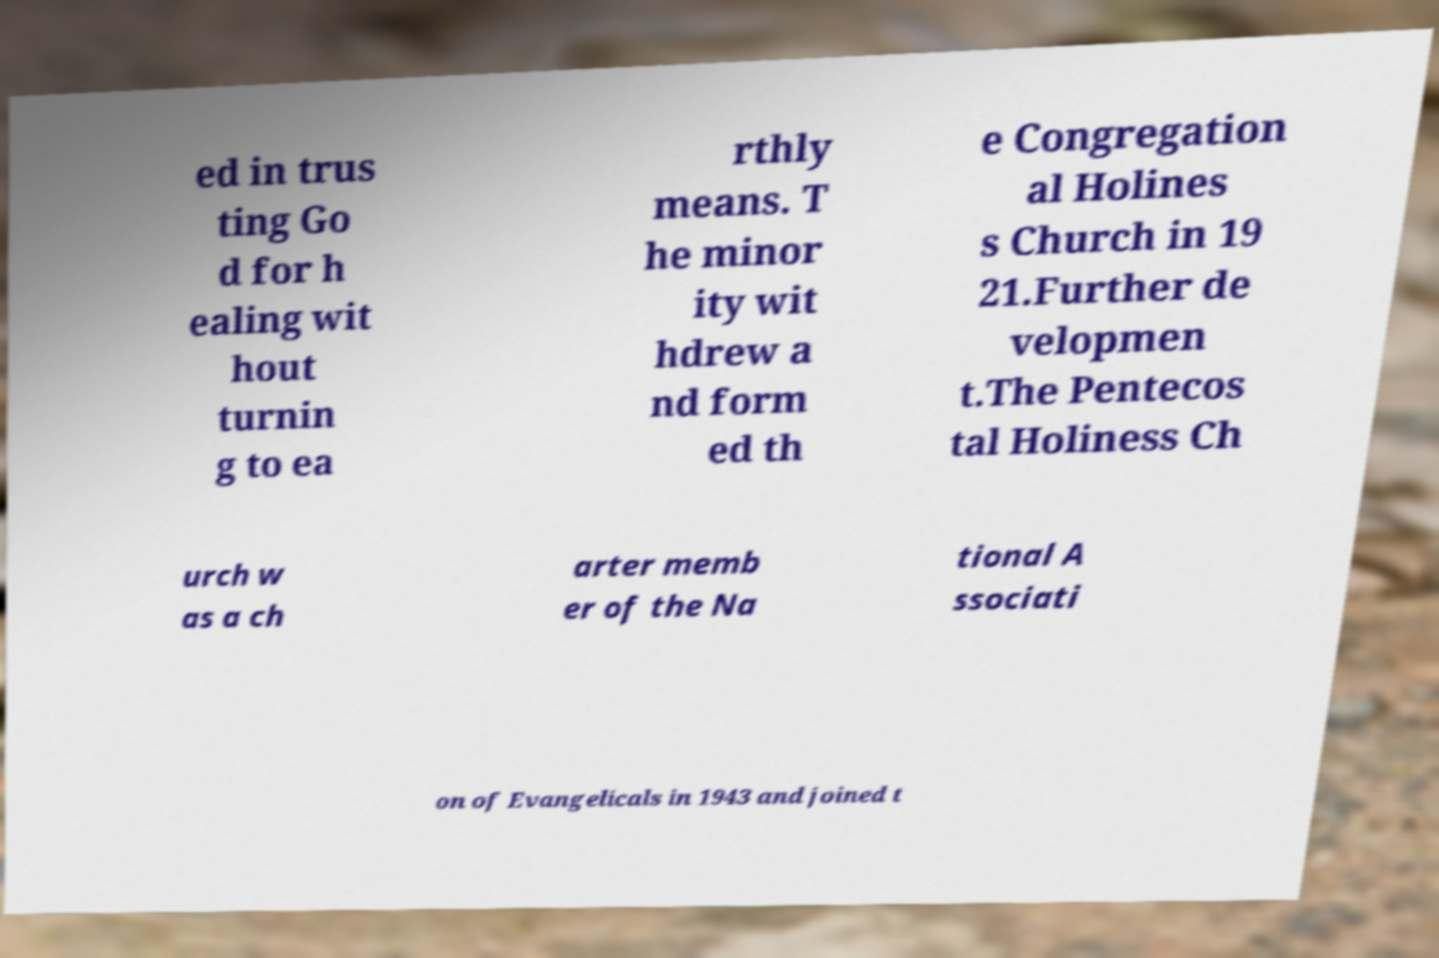I need the written content from this picture converted into text. Can you do that? ed in trus ting Go d for h ealing wit hout turnin g to ea rthly means. T he minor ity wit hdrew a nd form ed th e Congregation al Holines s Church in 19 21.Further de velopmen t.The Pentecos tal Holiness Ch urch w as a ch arter memb er of the Na tional A ssociati on of Evangelicals in 1943 and joined t 